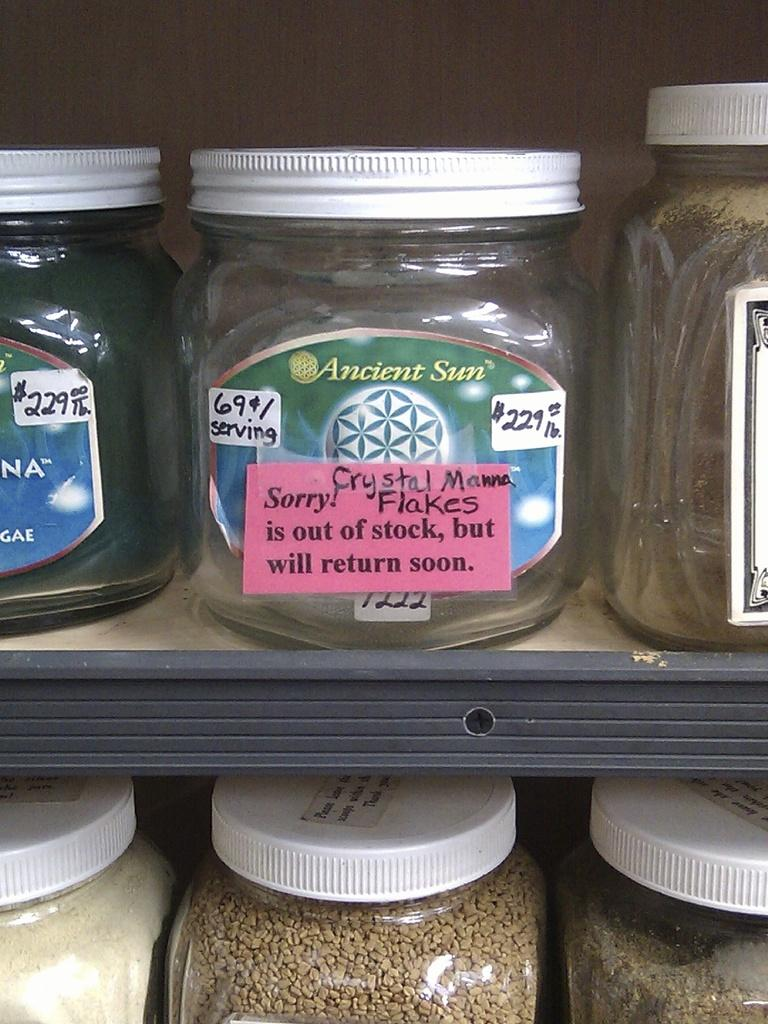<image>
Present a compact description of the photo's key features. Some jars on a shelf, one of which has a label saying it is out of stock. 